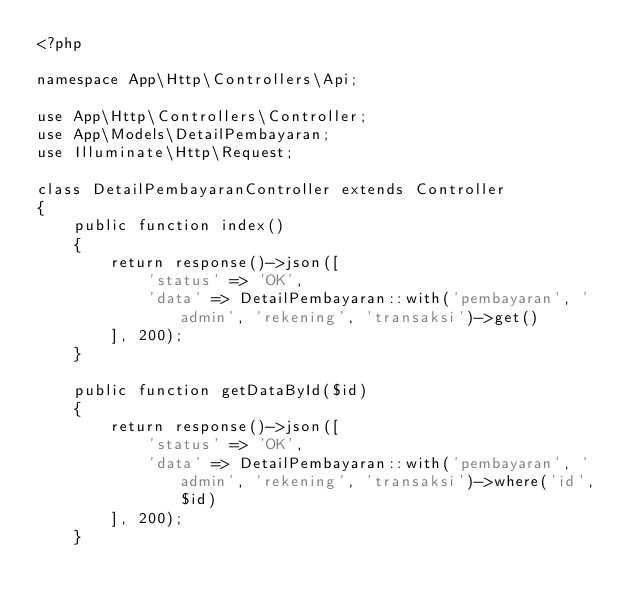Convert code to text. <code><loc_0><loc_0><loc_500><loc_500><_PHP_><?php

namespace App\Http\Controllers\Api;

use App\Http\Controllers\Controller;
use App\Models\DetailPembayaran;
use Illuminate\Http\Request;

class DetailPembayaranController extends Controller
{
    public function index()
    {
        return response()->json([
            'status' => 'OK',
            'data' => DetailPembayaran::with('pembayaran', 'admin', 'rekening', 'transaksi')->get()
        ], 200);
    }

    public function getDataById($id)
    {
        return response()->json([
            'status' => 'OK',
            'data' => DetailPembayaran::with('pembayaran', 'admin', 'rekening', 'transaksi')->where('id', $id)
        ], 200);
    }
</code> 